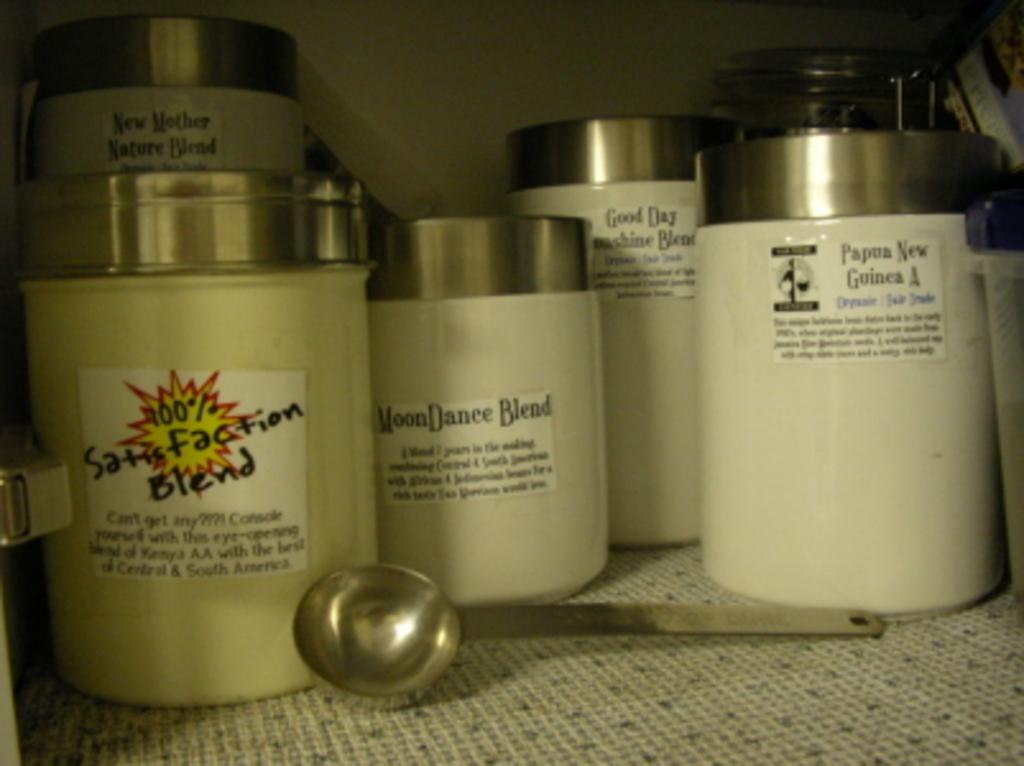<image>
Write a terse but informative summary of the picture. Bottles of different blends from Papua New Guinea 